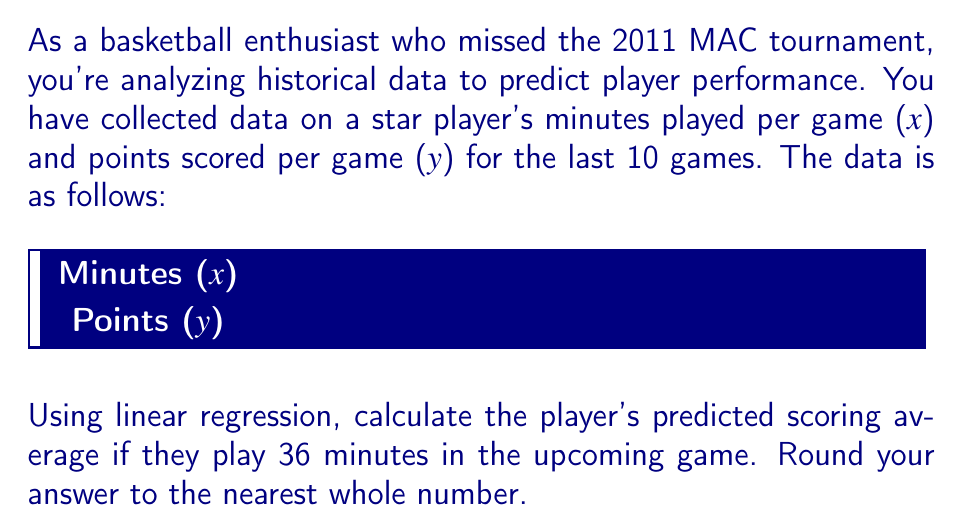Could you help me with this problem? To solve this problem using linear regression, we'll follow these steps:

1) First, calculate the means of x and y:
   $\bar{x} = \frac{20+25+28+30+32+35+38+40+42+45}{10} = 33.5$
   $\bar{y} = \frac{12+15+18+20+22+24+26+28+30+32}{10} = 22.7$

2) Calculate the slope (m) using the formula:
   $m = \frac{\sum(x_i - \bar{x})(y_i - \bar{y})}{\sum(x_i - \bar{x})^2}$

   Numerator: $(20-33.5)(12-22.7) + ... + (45-33.5)(32-22.7) = 1422.5$
   Denominator: $(20-33.5)^2 + ... + (45-33.5)^2 = 712.5$

   $m = \frac{1422.5}{712.5} = 2$

3) Calculate the y-intercept (b) using $y = mx + b$:
   $22.7 = 2(33.5) + b$
   $b = 22.7 - 67 = -44.3$

4) The linear regression equation is:
   $y = 2x - 44.3$

5) To predict the scoring average for 36 minutes:
   $y = 2(36) - 44.3 = 27.7$

6) Rounding to the nearest whole number:
   $27.7 \approx 28$

Therefore, the predicted scoring average for 36 minutes of play is 28 points.
Answer: 28 points 